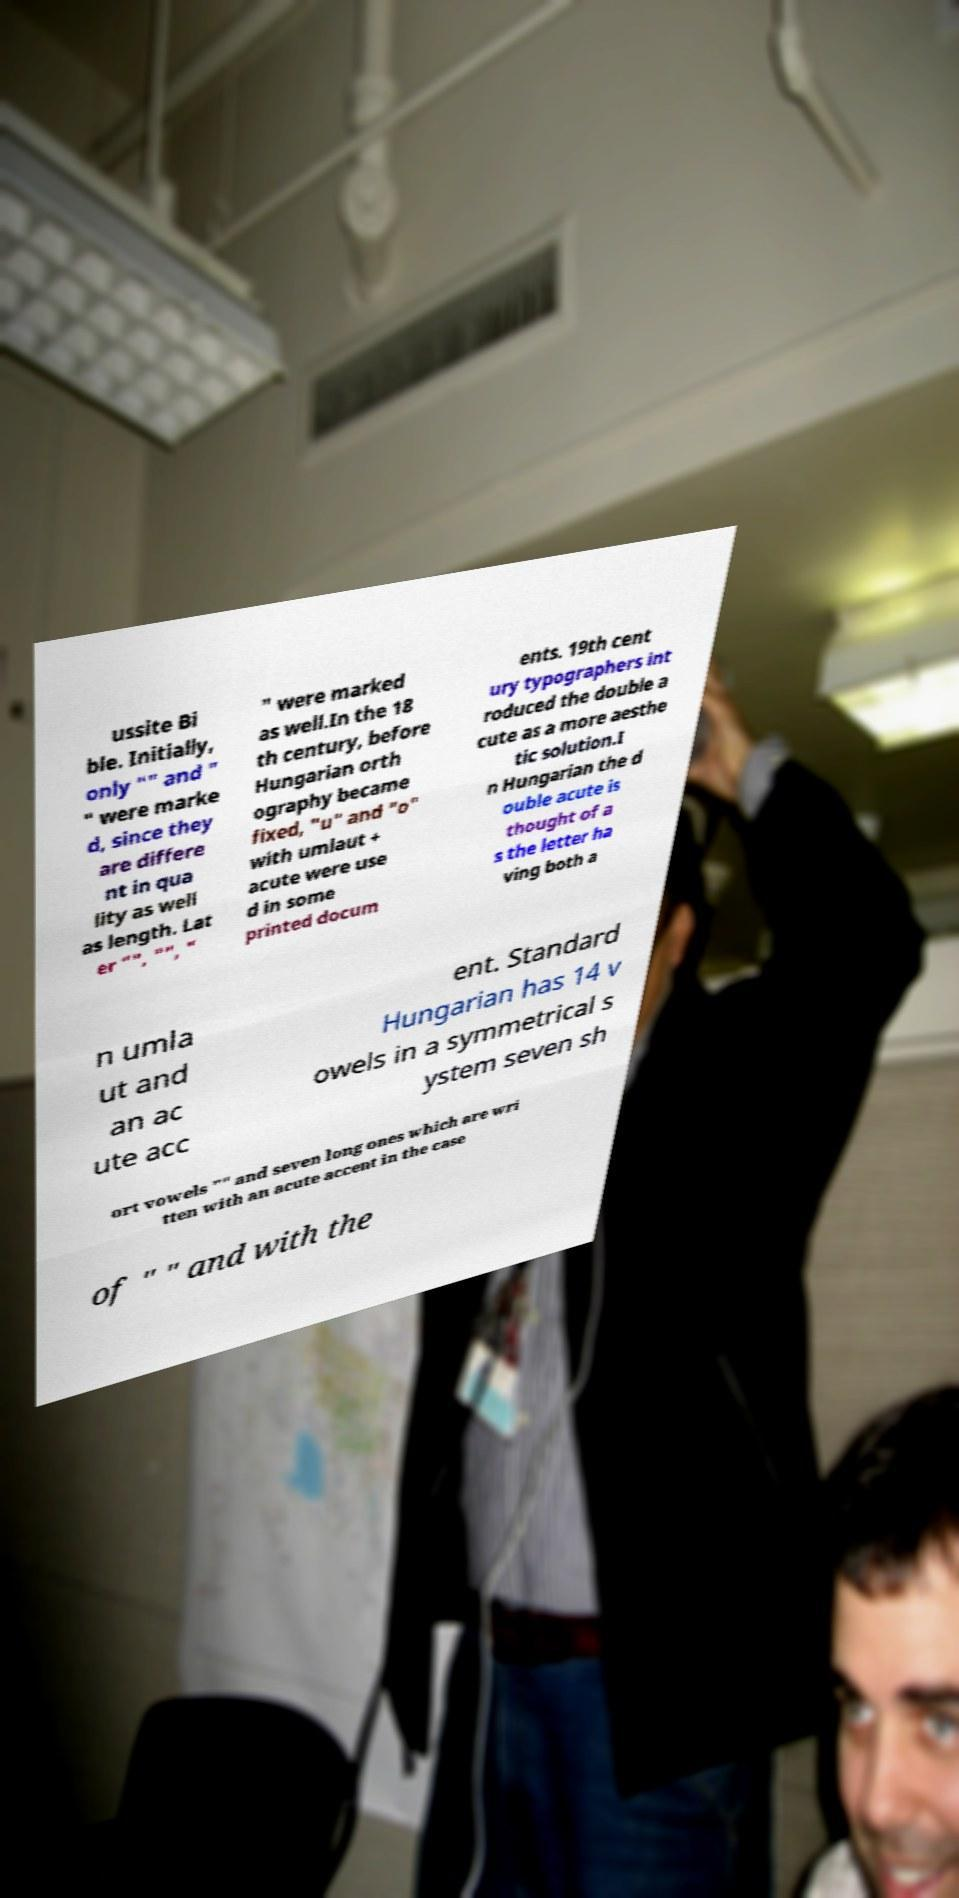Could you assist in decoding the text presented in this image and type it out clearly? ussite Bi ble. Initially, only "" and " " were marke d, since they are differe nt in qua lity as well as length. Lat er "", "", " " were marked as well.In the 18 th century, before Hungarian orth ography became fixed, "u" and "o" with umlaut + acute were use d in some printed docum ents. 19th cent ury typographers int roduced the double a cute as a more aesthe tic solution.I n Hungarian the d ouble acute is thought of a s the letter ha ving both a n umla ut and an ac ute acc ent. Standard Hungarian has 14 v owels in a symmetrical s ystem seven sh ort vowels "" and seven long ones which are wri tten with an acute accent in the case of " " and with the 